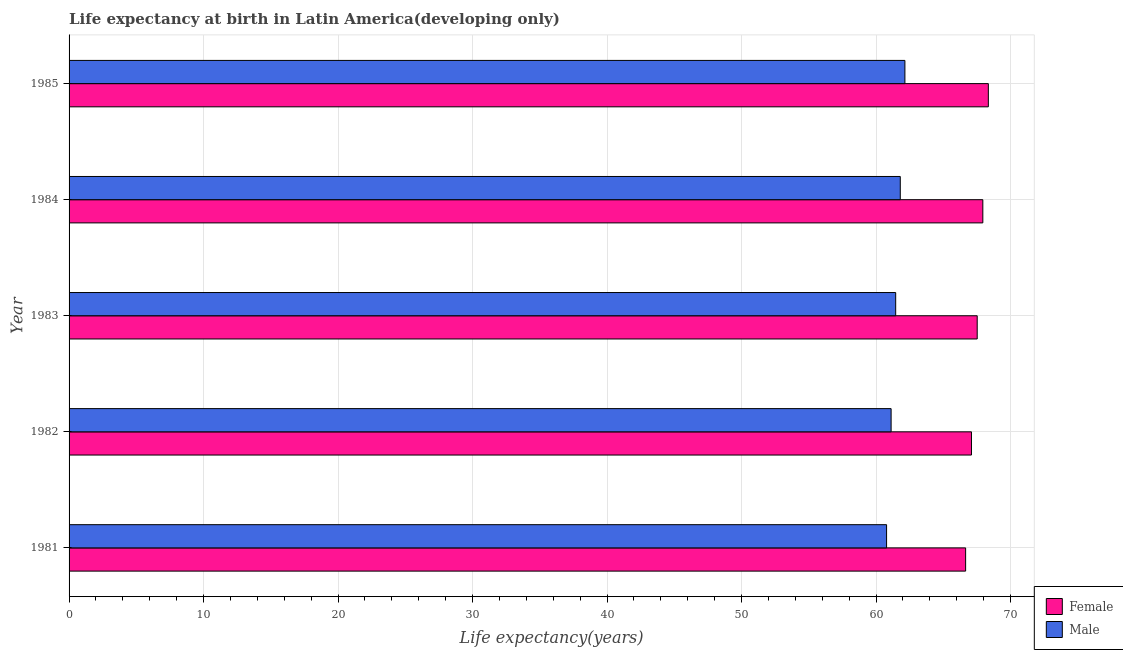How many different coloured bars are there?
Your response must be concise. 2. How many groups of bars are there?
Offer a very short reply. 5. What is the label of the 4th group of bars from the top?
Keep it short and to the point. 1982. In how many cases, is the number of bars for a given year not equal to the number of legend labels?
Offer a terse response. 0. What is the life expectancy(female) in 1981?
Your response must be concise. 66.66. Across all years, what is the maximum life expectancy(female)?
Keep it short and to the point. 68.35. Across all years, what is the minimum life expectancy(male)?
Keep it short and to the point. 60.79. In which year was the life expectancy(female) maximum?
Keep it short and to the point. 1985. What is the total life expectancy(female) in the graph?
Offer a terse response. 337.59. What is the difference between the life expectancy(female) in 1981 and that in 1985?
Provide a succinct answer. -1.69. What is the difference between the life expectancy(male) in 1985 and the life expectancy(female) in 1983?
Offer a terse response. -5.38. What is the average life expectancy(female) per year?
Your answer should be compact. 67.52. In the year 1981, what is the difference between the life expectancy(female) and life expectancy(male)?
Offer a terse response. 5.88. What is the difference between the highest and the second highest life expectancy(male)?
Provide a succinct answer. 0.34. What is the difference between the highest and the lowest life expectancy(male)?
Your answer should be very brief. 1.36. In how many years, is the life expectancy(male) greater than the average life expectancy(male) taken over all years?
Your answer should be compact. 2. Is the sum of the life expectancy(female) in 1982 and 1985 greater than the maximum life expectancy(male) across all years?
Provide a succinct answer. Yes. What does the 2nd bar from the top in 1982 represents?
Your answer should be very brief. Female. What does the 1st bar from the bottom in 1981 represents?
Make the answer very short. Female. How many bars are there?
Make the answer very short. 10. How many years are there in the graph?
Your answer should be compact. 5. Does the graph contain any zero values?
Your answer should be very brief. No. How are the legend labels stacked?
Offer a very short reply. Vertical. What is the title of the graph?
Offer a terse response. Life expectancy at birth in Latin America(developing only). Does "Primary" appear as one of the legend labels in the graph?
Offer a very short reply. No. What is the label or title of the X-axis?
Keep it short and to the point. Life expectancy(years). What is the Life expectancy(years) in Female in 1981?
Offer a terse response. 66.66. What is the Life expectancy(years) in Male in 1981?
Offer a terse response. 60.79. What is the Life expectancy(years) in Female in 1982?
Provide a succinct answer. 67.1. What is the Life expectancy(years) in Male in 1982?
Offer a terse response. 61.12. What is the Life expectancy(years) of Female in 1983?
Ensure brevity in your answer.  67.53. What is the Life expectancy(years) in Male in 1983?
Offer a terse response. 61.46. What is the Life expectancy(years) in Female in 1984?
Your answer should be compact. 67.94. What is the Life expectancy(years) in Male in 1984?
Offer a very short reply. 61.81. What is the Life expectancy(years) of Female in 1985?
Give a very brief answer. 68.35. What is the Life expectancy(years) of Male in 1985?
Provide a succinct answer. 62.15. Across all years, what is the maximum Life expectancy(years) of Female?
Offer a terse response. 68.35. Across all years, what is the maximum Life expectancy(years) in Male?
Make the answer very short. 62.15. Across all years, what is the minimum Life expectancy(years) in Female?
Give a very brief answer. 66.66. Across all years, what is the minimum Life expectancy(years) of Male?
Give a very brief answer. 60.79. What is the total Life expectancy(years) of Female in the graph?
Give a very brief answer. 337.59. What is the total Life expectancy(years) of Male in the graph?
Your response must be concise. 307.33. What is the difference between the Life expectancy(years) in Female in 1981 and that in 1982?
Your response must be concise. -0.43. What is the difference between the Life expectancy(years) in Male in 1981 and that in 1982?
Your answer should be very brief. -0.34. What is the difference between the Life expectancy(years) in Female in 1981 and that in 1983?
Your answer should be compact. -0.86. What is the difference between the Life expectancy(years) of Male in 1981 and that in 1983?
Make the answer very short. -0.68. What is the difference between the Life expectancy(years) in Female in 1981 and that in 1984?
Your answer should be very brief. -1.28. What is the difference between the Life expectancy(years) in Male in 1981 and that in 1984?
Your answer should be very brief. -1.02. What is the difference between the Life expectancy(years) of Female in 1981 and that in 1985?
Make the answer very short. -1.69. What is the difference between the Life expectancy(years) in Male in 1981 and that in 1985?
Provide a short and direct response. -1.36. What is the difference between the Life expectancy(years) of Female in 1982 and that in 1983?
Make the answer very short. -0.43. What is the difference between the Life expectancy(years) of Male in 1982 and that in 1983?
Provide a short and direct response. -0.34. What is the difference between the Life expectancy(years) of Female in 1982 and that in 1984?
Keep it short and to the point. -0.84. What is the difference between the Life expectancy(years) in Male in 1982 and that in 1984?
Make the answer very short. -0.68. What is the difference between the Life expectancy(years) of Female in 1982 and that in 1985?
Offer a terse response. -1.25. What is the difference between the Life expectancy(years) of Male in 1982 and that in 1985?
Offer a terse response. -1.02. What is the difference between the Life expectancy(years) of Female in 1983 and that in 1984?
Make the answer very short. -0.42. What is the difference between the Life expectancy(years) of Male in 1983 and that in 1984?
Provide a succinct answer. -0.34. What is the difference between the Life expectancy(years) in Female in 1983 and that in 1985?
Offer a very short reply. -0.83. What is the difference between the Life expectancy(years) in Male in 1983 and that in 1985?
Offer a terse response. -0.69. What is the difference between the Life expectancy(years) of Female in 1984 and that in 1985?
Make the answer very short. -0.41. What is the difference between the Life expectancy(years) in Male in 1984 and that in 1985?
Offer a terse response. -0.34. What is the difference between the Life expectancy(years) of Female in 1981 and the Life expectancy(years) of Male in 1982?
Your response must be concise. 5.54. What is the difference between the Life expectancy(years) in Female in 1981 and the Life expectancy(years) in Male in 1983?
Keep it short and to the point. 5.2. What is the difference between the Life expectancy(years) of Female in 1981 and the Life expectancy(years) of Male in 1984?
Offer a very short reply. 4.86. What is the difference between the Life expectancy(years) in Female in 1981 and the Life expectancy(years) in Male in 1985?
Your answer should be compact. 4.52. What is the difference between the Life expectancy(years) of Female in 1982 and the Life expectancy(years) of Male in 1983?
Offer a very short reply. 5.64. What is the difference between the Life expectancy(years) of Female in 1982 and the Life expectancy(years) of Male in 1984?
Your answer should be very brief. 5.29. What is the difference between the Life expectancy(years) in Female in 1982 and the Life expectancy(years) in Male in 1985?
Your answer should be very brief. 4.95. What is the difference between the Life expectancy(years) of Female in 1983 and the Life expectancy(years) of Male in 1984?
Ensure brevity in your answer.  5.72. What is the difference between the Life expectancy(years) in Female in 1983 and the Life expectancy(years) in Male in 1985?
Offer a terse response. 5.38. What is the difference between the Life expectancy(years) in Female in 1984 and the Life expectancy(years) in Male in 1985?
Provide a short and direct response. 5.79. What is the average Life expectancy(years) in Female per year?
Offer a terse response. 67.52. What is the average Life expectancy(years) in Male per year?
Your answer should be very brief. 61.47. In the year 1981, what is the difference between the Life expectancy(years) of Female and Life expectancy(years) of Male?
Provide a short and direct response. 5.88. In the year 1982, what is the difference between the Life expectancy(years) of Female and Life expectancy(years) of Male?
Make the answer very short. 5.98. In the year 1983, what is the difference between the Life expectancy(years) of Female and Life expectancy(years) of Male?
Provide a short and direct response. 6.06. In the year 1984, what is the difference between the Life expectancy(years) of Female and Life expectancy(years) of Male?
Provide a short and direct response. 6.14. In the year 1985, what is the difference between the Life expectancy(years) of Female and Life expectancy(years) of Male?
Ensure brevity in your answer.  6.2. What is the ratio of the Life expectancy(years) in Female in 1981 to that in 1982?
Your response must be concise. 0.99. What is the ratio of the Life expectancy(years) of Male in 1981 to that in 1982?
Offer a terse response. 0.99. What is the ratio of the Life expectancy(years) of Female in 1981 to that in 1983?
Give a very brief answer. 0.99. What is the ratio of the Life expectancy(years) of Female in 1981 to that in 1984?
Offer a very short reply. 0.98. What is the ratio of the Life expectancy(years) in Male in 1981 to that in 1984?
Offer a very short reply. 0.98. What is the ratio of the Life expectancy(years) in Female in 1981 to that in 1985?
Keep it short and to the point. 0.98. What is the ratio of the Life expectancy(years) in Male in 1981 to that in 1985?
Offer a terse response. 0.98. What is the ratio of the Life expectancy(years) of Female in 1982 to that in 1983?
Your answer should be compact. 0.99. What is the ratio of the Life expectancy(years) of Male in 1982 to that in 1983?
Provide a succinct answer. 0.99. What is the ratio of the Life expectancy(years) in Female in 1982 to that in 1984?
Your response must be concise. 0.99. What is the ratio of the Life expectancy(years) in Male in 1982 to that in 1984?
Give a very brief answer. 0.99. What is the ratio of the Life expectancy(years) in Female in 1982 to that in 1985?
Keep it short and to the point. 0.98. What is the ratio of the Life expectancy(years) in Male in 1982 to that in 1985?
Keep it short and to the point. 0.98. What is the ratio of the Life expectancy(years) of Female in 1983 to that in 1985?
Make the answer very short. 0.99. What is the ratio of the Life expectancy(years) in Male in 1983 to that in 1985?
Offer a very short reply. 0.99. What is the ratio of the Life expectancy(years) in Male in 1984 to that in 1985?
Your response must be concise. 0.99. What is the difference between the highest and the second highest Life expectancy(years) of Female?
Provide a succinct answer. 0.41. What is the difference between the highest and the second highest Life expectancy(years) of Male?
Ensure brevity in your answer.  0.34. What is the difference between the highest and the lowest Life expectancy(years) of Female?
Give a very brief answer. 1.69. What is the difference between the highest and the lowest Life expectancy(years) of Male?
Your response must be concise. 1.36. 